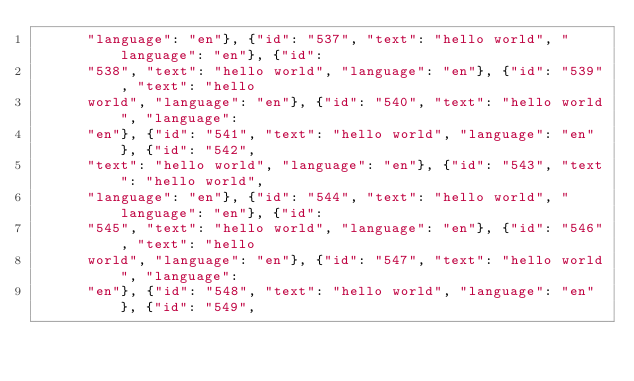Convert code to text. <code><loc_0><loc_0><loc_500><loc_500><_YAML_>      "language": "en"}, {"id": "537", "text": "hello world", "language": "en"}, {"id":
      "538", "text": "hello world", "language": "en"}, {"id": "539", "text": "hello
      world", "language": "en"}, {"id": "540", "text": "hello world", "language":
      "en"}, {"id": "541", "text": "hello world", "language": "en"}, {"id": "542",
      "text": "hello world", "language": "en"}, {"id": "543", "text": "hello world",
      "language": "en"}, {"id": "544", "text": "hello world", "language": "en"}, {"id":
      "545", "text": "hello world", "language": "en"}, {"id": "546", "text": "hello
      world", "language": "en"}, {"id": "547", "text": "hello world", "language":
      "en"}, {"id": "548", "text": "hello world", "language": "en"}, {"id": "549",</code> 